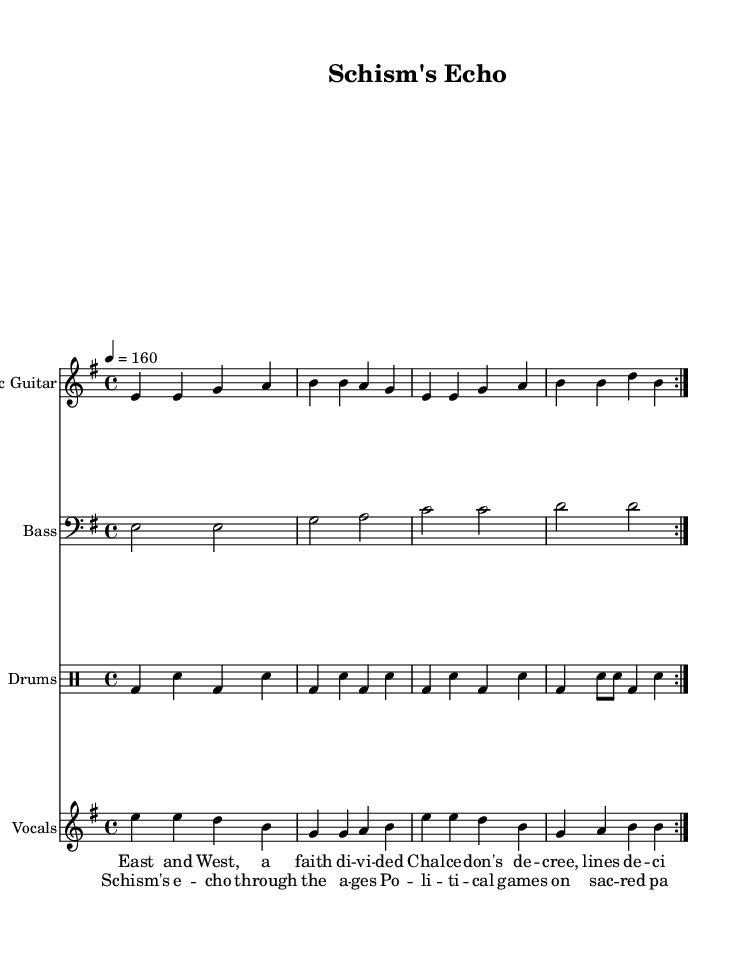What is the key signature of this music? The key signature is E minor, which has one sharp (F#). This is indicated at the beginning of the staff, where the sharp note is indicated.
Answer: E minor What is the time signature of the music? The time signature is 4/4, which means there are four beats in each measure and the quarter note gets one beat. This is shown at the beginning of the piece, right after the key signature.
Answer: 4/4 What is the tempo marking of this piece? The tempo marking is 160, indicated with the note value "4 = 160" meaning there are 160 quarter note beats per minute. This provides a fast-paced affinity typical of punk music.
Answer: 160 How many volta sections are in the electric guitar part? There are 2 volta sections indicated by the repeat signs. The repeat term "volta" suggests that the section is played twice through.
Answer: 2 What is the lyrical theme expressed in the chorus? The lyrical theme in the chorus focuses on the historical and political issues stemming from schism, specifically "Schism's echo through the ages" and "Political games on sacred pages". This suggests a critique of the political influence in religious history.
Answer: Schism and politics What instrument plays the bass part? The instrument indicated for the bass part is "Bass". This can be seen above the bass guitar staff.
Answer: Bass What genre does this music represent? The genre represented by this music is Punk, characterized by its fast tempo, political themes, and straightforward structure. This is inferred from the aggressive lyrics and the rhythmic pattern typical of punk songs.
Answer: Punk 